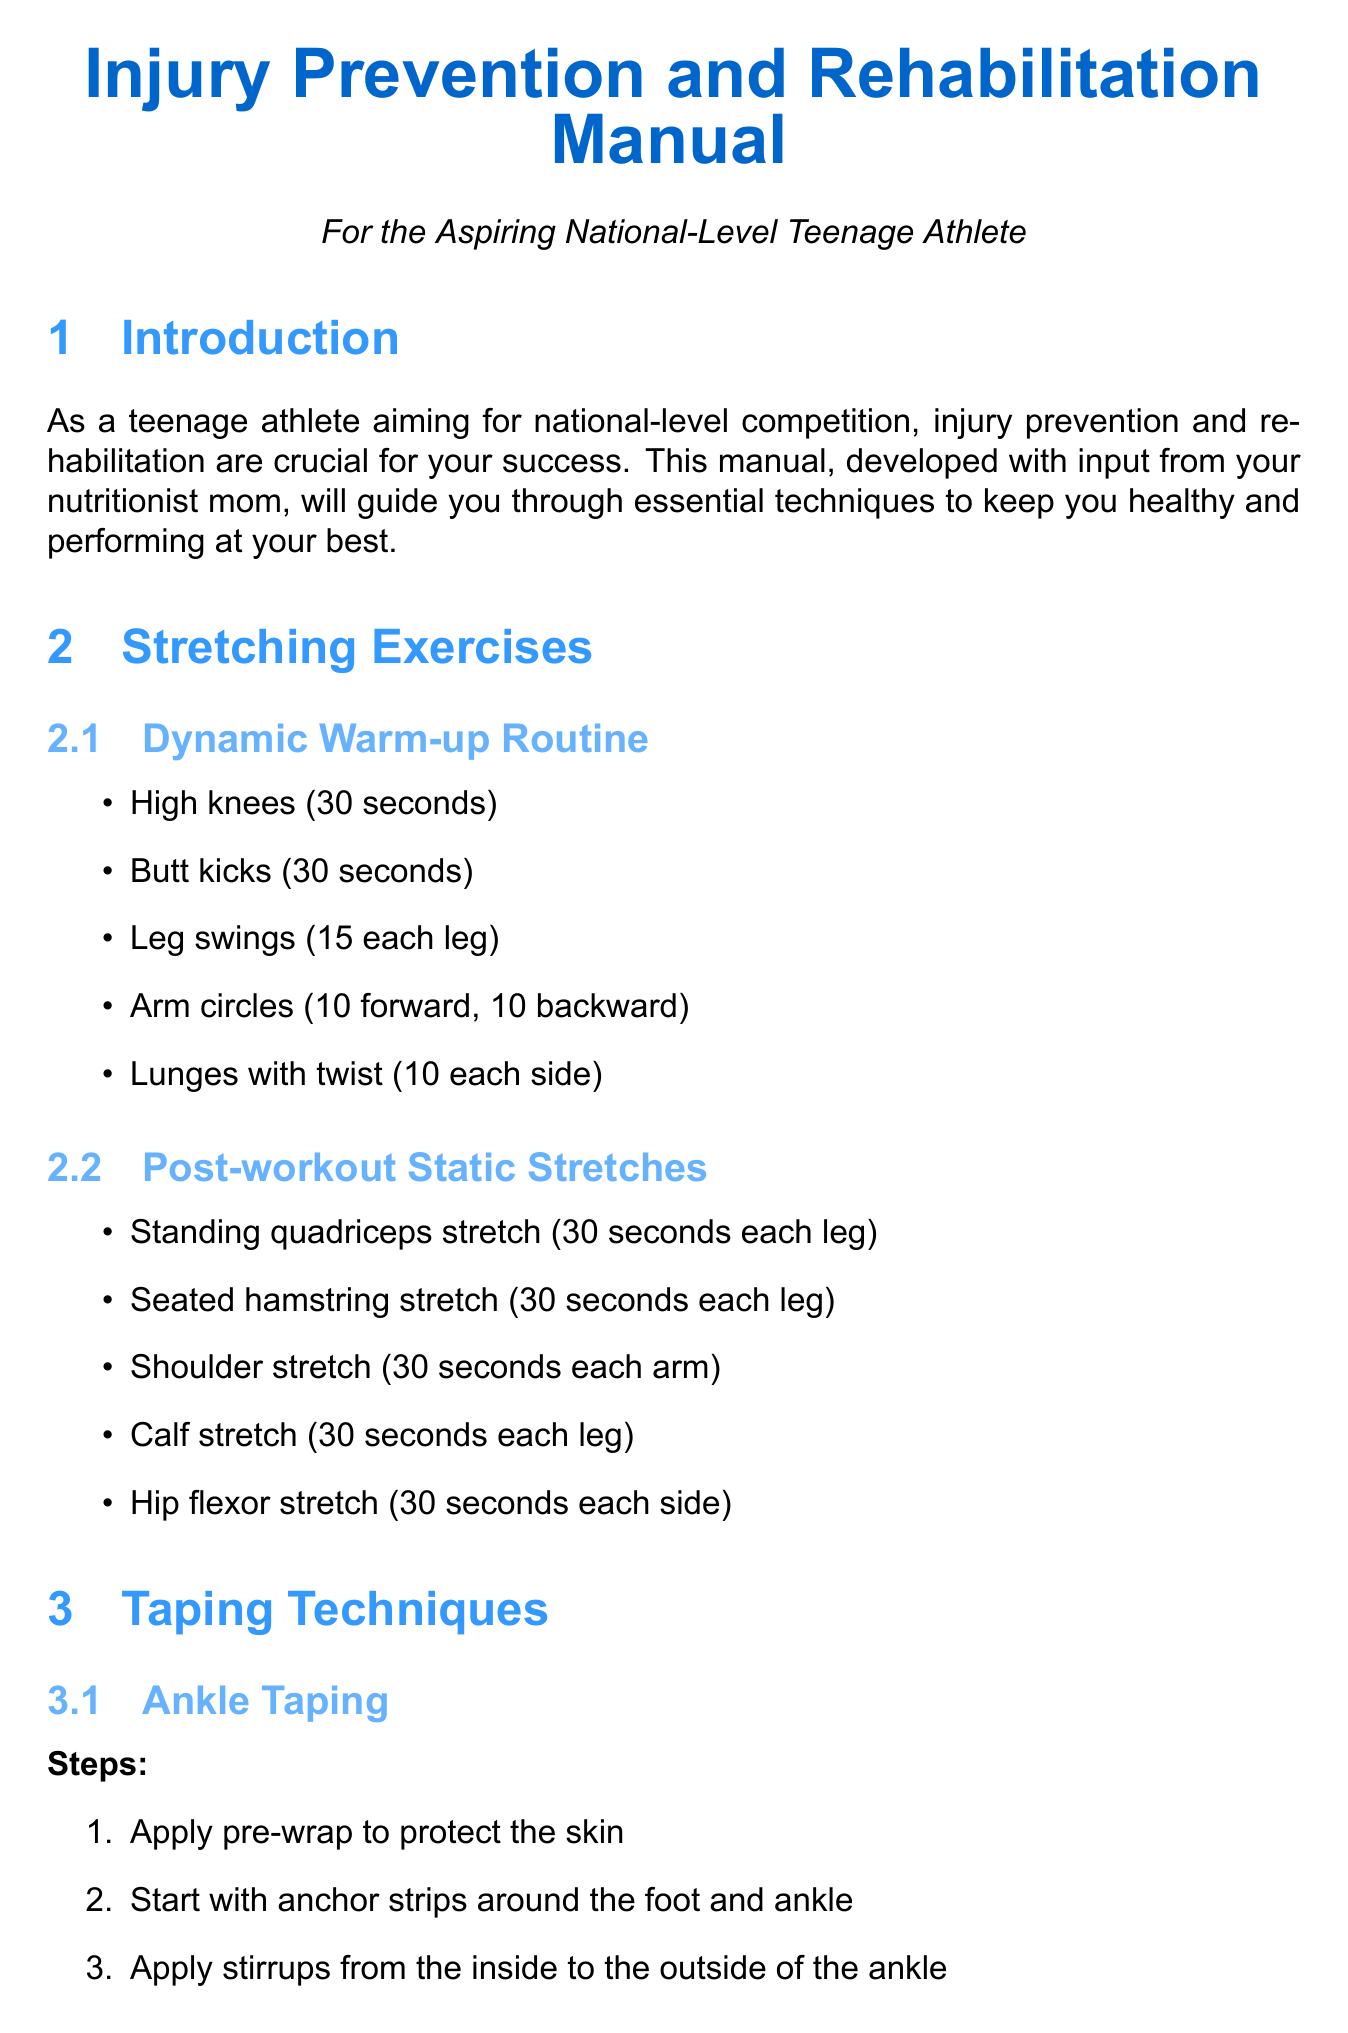What is the title of the manual? The title of the manual is mentioned at the beginning and provides insight into its purpose.
Answer: Injury Prevention and Rehabilitation Manual How long should you hold the standing quadriceps stretch? This duration is specified in the post-workout static stretches section.
Answer: 30 seconds each leg What is the first step in ankle taping? The steps are listed in the taping techniques section, detailing the initial action required for ankle taping.
Answer: Apply pre-wrap to protect the skin What are shin splints? The document describes shin splints in the common sports injuries section, noting it involves pain along a specific bone.
Answer: Pain along the inner edge of the shinbone How many dynamic warm-up exercises are listed? The number of exercises is specified in the dynamic warm-up routine section.
Answer: 5 What nutritional element should you consume to support muscle repair? This is indicated in the nutrition for injury prevention and recovery section, highlighting the importance of certain nutrients.
Answer: Protein What is the RICE protocol? The RICE protocol is detailed as part of muscle strain treatment, giving a total of four components.
Answer: Rest, Ice, Compression, Elevation What should you do after applying ice for 20 minutes on a sprain? The treatment steps clarify the immediate actions to take following ice application.
Answer: Apply ice for 20 minutes every 2-3 hours How can visualization techniques help during recovery? The mental health strategies section includes this technique's role in maintaining skills during recovery.
Answer: Maintain skills during recovery 